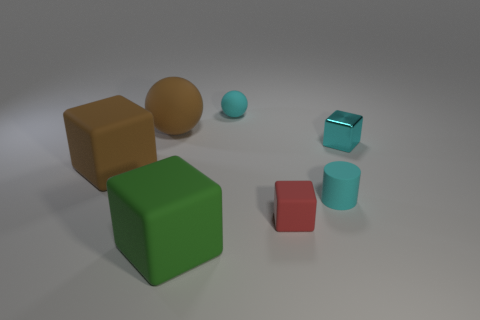Subtract all metallic cubes. How many cubes are left? 3 Add 1 tiny cyan cubes. How many objects exist? 8 Subtract all cylinders. How many objects are left? 6 Subtract all brown balls. How many balls are left? 1 Subtract all large brown rubber things. Subtract all cyan cylinders. How many objects are left? 4 Add 7 large brown rubber spheres. How many large brown rubber spheres are left? 8 Add 2 cyan blocks. How many cyan blocks exist? 3 Subtract 0 gray cylinders. How many objects are left? 7 Subtract 3 cubes. How many cubes are left? 1 Subtract all cyan spheres. Subtract all green cylinders. How many spheres are left? 1 